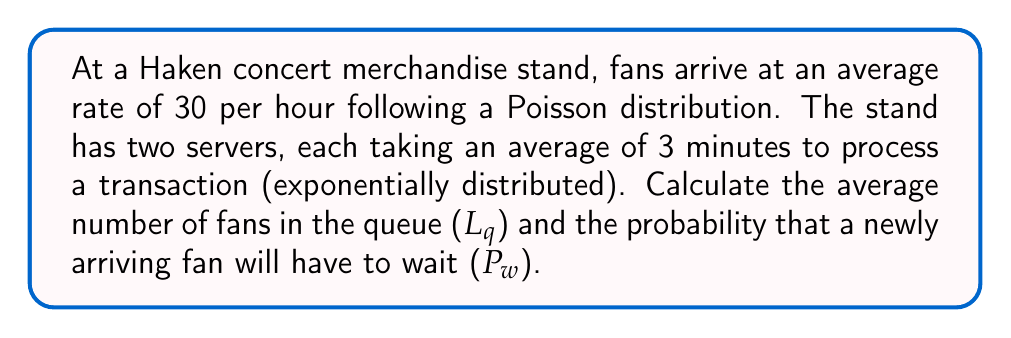Can you answer this question? Let's approach this step-by-step using the M/M/s queueing model:

1) First, let's define our parameters:
   λ = arrival rate = 30 fans/hour
   μ = service rate per server = 20 fans/hour (1 / (3/60) = 20)
   s = number of servers = 2

2) Calculate the utilization factor ρ:
   $$\rho = \frac{\lambda}{s\mu} = \frac{30}{2 * 20} = 0.75$$

3) Calculate P0, the probability of zero customers in the system:
   $$P_0 = \left[\sum_{n=0}^{s-1}\frac{(s\rho)^n}{n!} + \frac{(s\rho)^s}{s!(1-\rho)}\right]^{-1}$$
   $$P_0 = \left[1 + \frac{(2*0.75)^1}{1!} + \frac{(2*0.75)^2}{2!(1-0.75)}\right]^{-1} = 0.1579$$

4) Calculate Lq, the average number of customers in the queue:
   $$L_q = \frac{P_0(λ/μ)^s\rho}{s!(1-\rho)^2} = \frac{0.1579 * (30/20)^2 * 0.75}{2!(1-0.75)^2} = 2.25$$

5) Calculate Pw, the probability that an arriving customer has to wait:
   $$P_w = \frac{L_q}{\rho s} = \frac{2.25}{0.75 * 2} = 1.5$$

   However, probability cannot exceed 1, so we cap this at 1.
Answer: Lq = 2.25 fans, Pw = 1 (100%) 